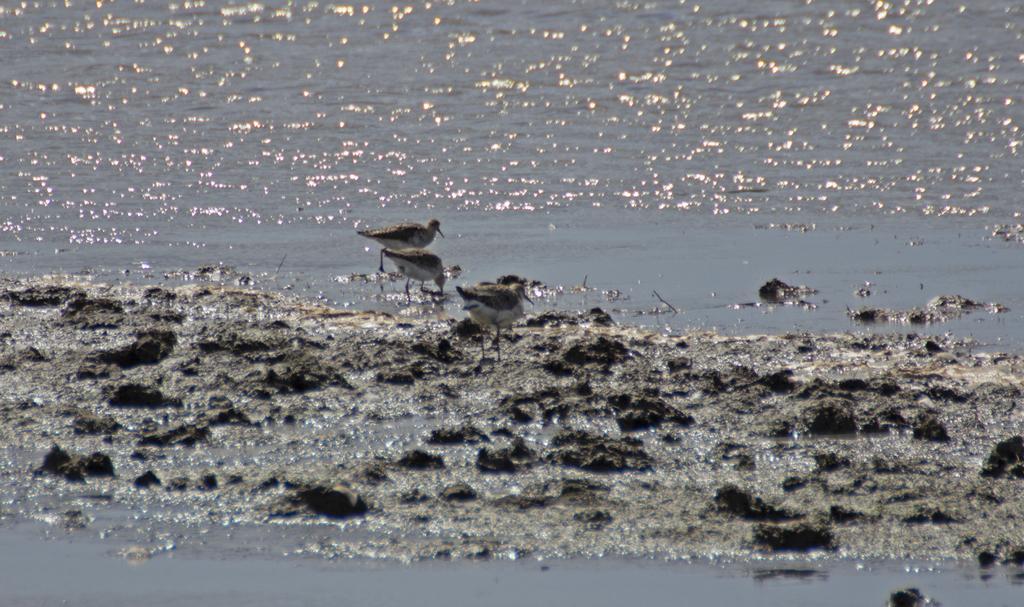Can you describe this image briefly? This picture shows few birds in the mud and we see water. 